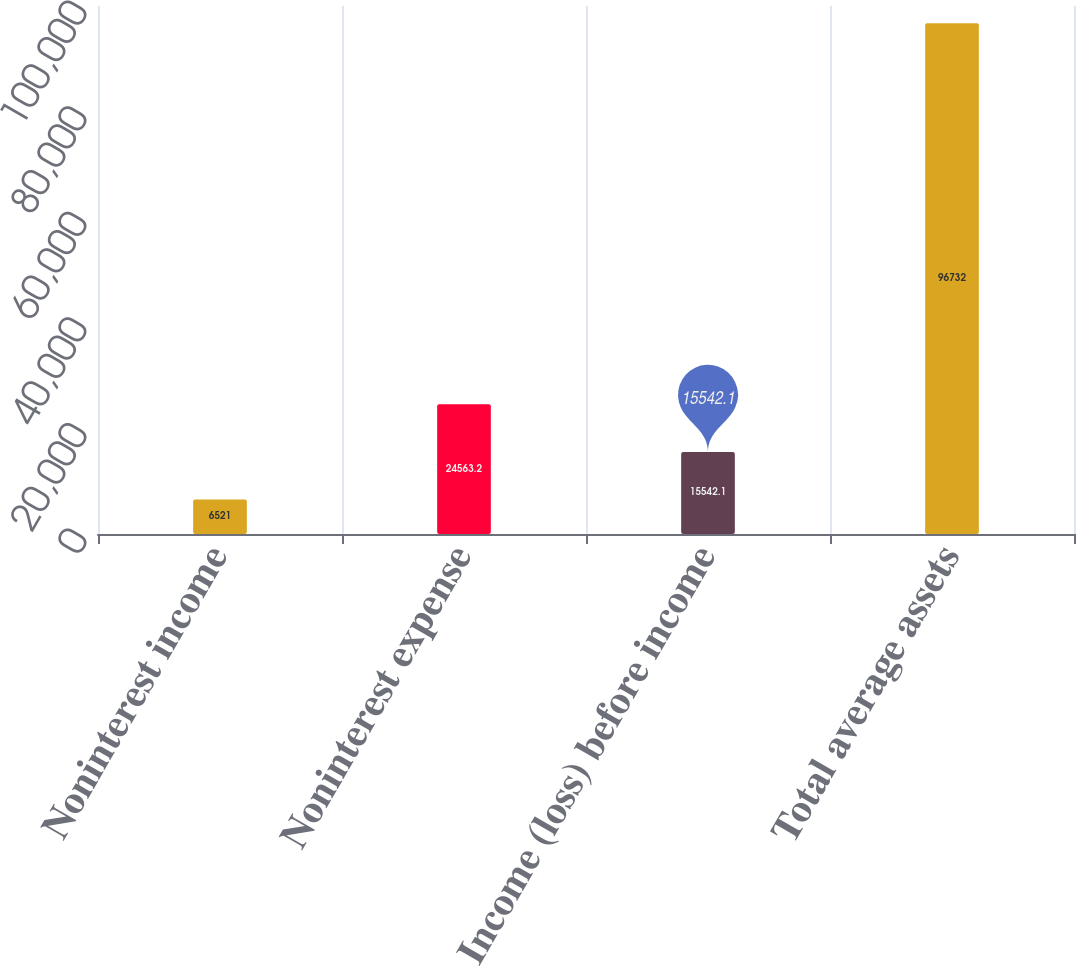<chart> <loc_0><loc_0><loc_500><loc_500><bar_chart><fcel>Noninterest income<fcel>Noninterest expense<fcel>Income (loss) before income<fcel>Total average assets<nl><fcel>6521<fcel>24563.2<fcel>15542.1<fcel>96732<nl></chart> 